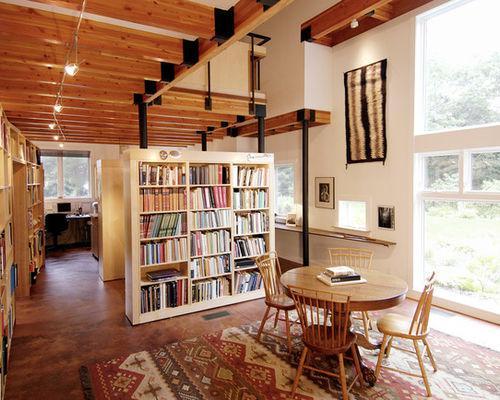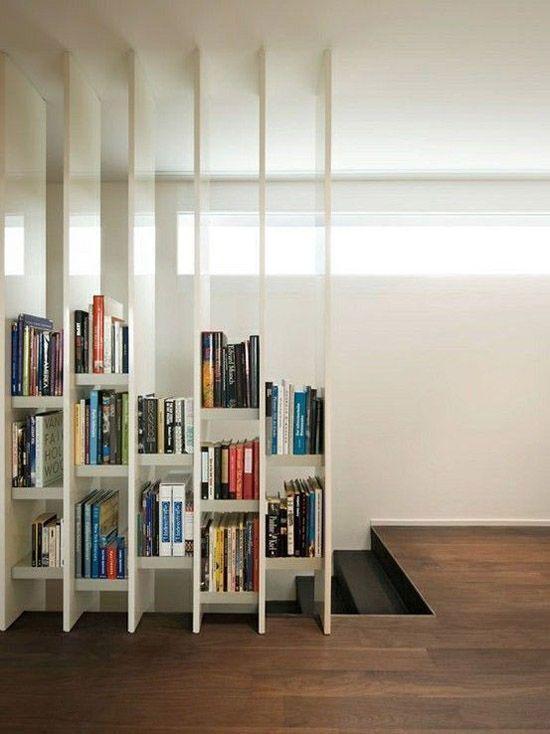The first image is the image on the left, the second image is the image on the right. Assess this claim about the two images: "There is are three door windows separating two rooms with at least one painted white.". Correct or not? Answer yes or no. No. 